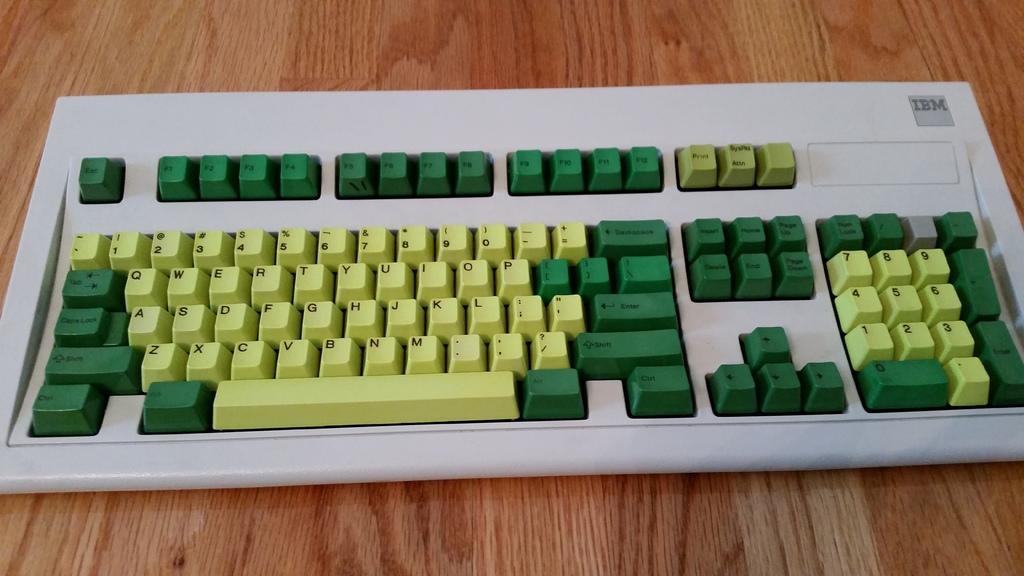What company logo is printed on the keyboard?
Keep it short and to the point. Ibm. 